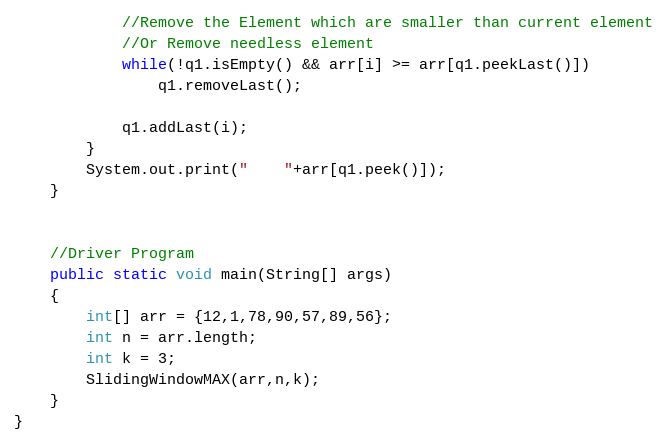Convert code to text. <code><loc_0><loc_0><loc_500><loc_500><_Java_>            //Remove the Element which are smaller than current element
            //Or Remove needless element
            while(!q1.isEmpty() && arr[i] >= arr[q1.peekLast()])
                q1.removeLast();

            q1.addLast(i);
        }
        System.out.print("    "+arr[q1.peek()]);
    }


    //Driver Program
    public static void main(String[] args)
    {
        int[] arr = {12,1,78,90,57,89,56};
        int n = arr.length;
        int k = 3;
        SlidingWindowMAX(arr,n,k);
    }
}
</code> 